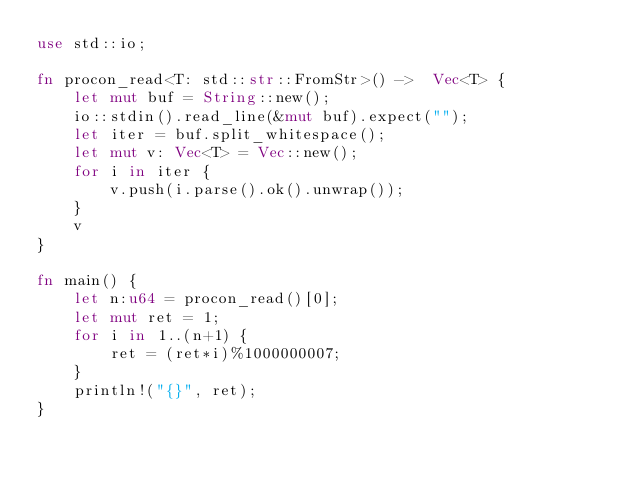Convert code to text. <code><loc_0><loc_0><loc_500><loc_500><_Rust_>use std::io;

fn procon_read<T: std::str::FromStr>() ->  Vec<T> {
	let mut buf = String::new();
	io::stdin().read_line(&mut buf).expect("");
	let iter = buf.split_whitespace();
	let mut v: Vec<T> = Vec::new();
	for i in iter {
		v.push(i.parse().ok().unwrap());
	}
	v
}

fn main() {
	let n:u64 = procon_read()[0];
	let mut ret = 1;
	for i in 1..(n+1) {
		ret = (ret*i)%1000000007;
	}
	println!("{}", ret);
}</code> 